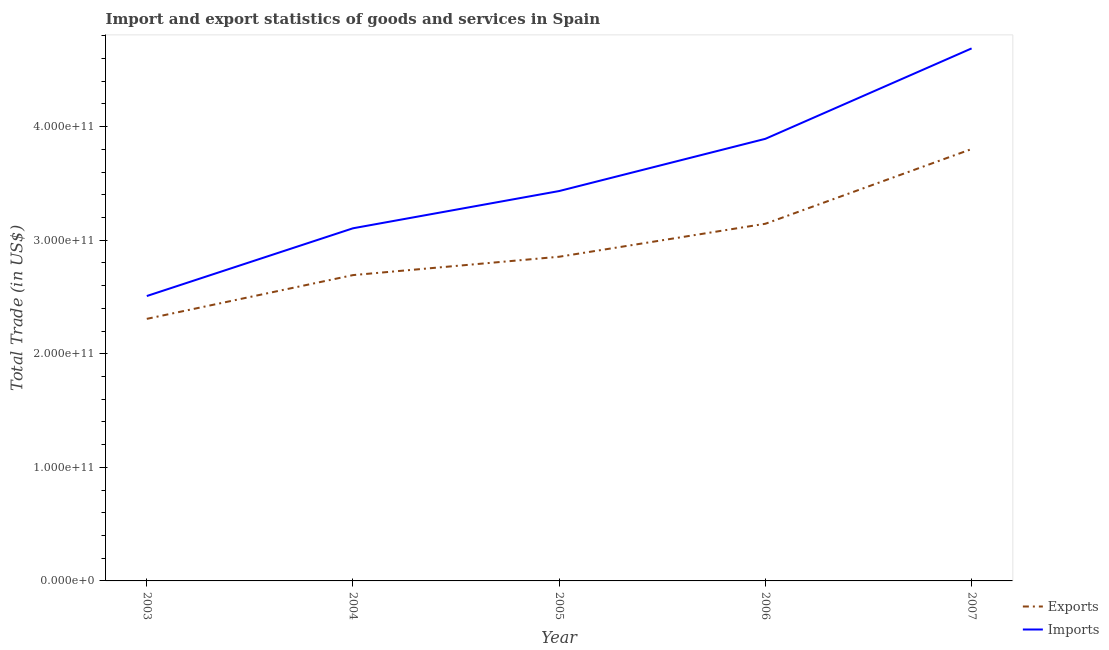How many different coloured lines are there?
Your answer should be compact. 2. What is the imports of goods and services in 2003?
Offer a very short reply. 2.51e+11. Across all years, what is the maximum export of goods and services?
Your answer should be very brief. 3.80e+11. Across all years, what is the minimum export of goods and services?
Ensure brevity in your answer.  2.31e+11. In which year was the imports of goods and services maximum?
Your answer should be compact. 2007. What is the total export of goods and services in the graph?
Keep it short and to the point. 1.48e+12. What is the difference between the export of goods and services in 2005 and that in 2007?
Offer a terse response. -9.48e+1. What is the difference between the export of goods and services in 2005 and the imports of goods and services in 2007?
Give a very brief answer. -1.83e+11. What is the average imports of goods and services per year?
Provide a short and direct response. 3.53e+11. In the year 2007, what is the difference between the imports of goods and services and export of goods and services?
Your answer should be very brief. 8.86e+1. What is the ratio of the export of goods and services in 2003 to that in 2004?
Keep it short and to the point. 0.86. What is the difference between the highest and the second highest export of goods and services?
Ensure brevity in your answer.  6.58e+1. What is the difference between the highest and the lowest export of goods and services?
Your answer should be compact. 1.50e+11. Is the sum of the export of goods and services in 2006 and 2007 greater than the maximum imports of goods and services across all years?
Offer a very short reply. Yes. Does the imports of goods and services monotonically increase over the years?
Give a very brief answer. Yes. How many lines are there?
Your answer should be very brief. 2. What is the difference between two consecutive major ticks on the Y-axis?
Offer a very short reply. 1.00e+11. Does the graph contain any zero values?
Your answer should be very brief. No. Does the graph contain grids?
Provide a short and direct response. No. How many legend labels are there?
Your response must be concise. 2. What is the title of the graph?
Keep it short and to the point. Import and export statistics of goods and services in Spain. What is the label or title of the X-axis?
Offer a very short reply. Year. What is the label or title of the Y-axis?
Your answer should be very brief. Total Trade (in US$). What is the Total Trade (in US$) in Exports in 2003?
Give a very brief answer. 2.31e+11. What is the Total Trade (in US$) of Imports in 2003?
Your answer should be very brief. 2.51e+11. What is the Total Trade (in US$) of Exports in 2004?
Offer a terse response. 2.69e+11. What is the Total Trade (in US$) in Imports in 2004?
Offer a terse response. 3.11e+11. What is the Total Trade (in US$) of Exports in 2005?
Offer a very short reply. 2.85e+11. What is the Total Trade (in US$) of Imports in 2005?
Keep it short and to the point. 3.43e+11. What is the Total Trade (in US$) of Exports in 2006?
Your answer should be very brief. 3.15e+11. What is the Total Trade (in US$) of Imports in 2006?
Offer a terse response. 3.89e+11. What is the Total Trade (in US$) of Exports in 2007?
Provide a succinct answer. 3.80e+11. What is the Total Trade (in US$) of Imports in 2007?
Make the answer very short. 4.69e+11. Across all years, what is the maximum Total Trade (in US$) in Exports?
Make the answer very short. 3.80e+11. Across all years, what is the maximum Total Trade (in US$) of Imports?
Your response must be concise. 4.69e+11. Across all years, what is the minimum Total Trade (in US$) of Exports?
Your response must be concise. 2.31e+11. Across all years, what is the minimum Total Trade (in US$) of Imports?
Offer a very short reply. 2.51e+11. What is the total Total Trade (in US$) in Exports in the graph?
Keep it short and to the point. 1.48e+12. What is the total Total Trade (in US$) of Imports in the graph?
Your answer should be very brief. 1.76e+12. What is the difference between the Total Trade (in US$) in Exports in 2003 and that in 2004?
Your response must be concise. -3.85e+1. What is the difference between the Total Trade (in US$) of Imports in 2003 and that in 2004?
Your answer should be compact. -5.97e+1. What is the difference between the Total Trade (in US$) of Exports in 2003 and that in 2005?
Ensure brevity in your answer.  -5.47e+1. What is the difference between the Total Trade (in US$) in Imports in 2003 and that in 2005?
Offer a terse response. -9.25e+1. What is the difference between the Total Trade (in US$) in Exports in 2003 and that in 2006?
Provide a short and direct response. -8.37e+1. What is the difference between the Total Trade (in US$) of Imports in 2003 and that in 2006?
Provide a succinct answer. -1.38e+11. What is the difference between the Total Trade (in US$) in Exports in 2003 and that in 2007?
Offer a very short reply. -1.50e+11. What is the difference between the Total Trade (in US$) in Imports in 2003 and that in 2007?
Provide a succinct answer. -2.18e+11. What is the difference between the Total Trade (in US$) in Exports in 2004 and that in 2005?
Offer a terse response. -1.62e+1. What is the difference between the Total Trade (in US$) in Imports in 2004 and that in 2005?
Your response must be concise. -3.28e+1. What is the difference between the Total Trade (in US$) in Exports in 2004 and that in 2006?
Offer a terse response. -4.52e+1. What is the difference between the Total Trade (in US$) in Imports in 2004 and that in 2006?
Your answer should be very brief. -7.88e+1. What is the difference between the Total Trade (in US$) in Exports in 2004 and that in 2007?
Your answer should be compact. -1.11e+11. What is the difference between the Total Trade (in US$) of Imports in 2004 and that in 2007?
Make the answer very short. -1.58e+11. What is the difference between the Total Trade (in US$) of Exports in 2005 and that in 2006?
Offer a terse response. -2.90e+1. What is the difference between the Total Trade (in US$) in Imports in 2005 and that in 2006?
Your answer should be very brief. -4.60e+1. What is the difference between the Total Trade (in US$) in Exports in 2005 and that in 2007?
Keep it short and to the point. -9.48e+1. What is the difference between the Total Trade (in US$) in Imports in 2005 and that in 2007?
Your response must be concise. -1.26e+11. What is the difference between the Total Trade (in US$) in Exports in 2006 and that in 2007?
Make the answer very short. -6.58e+1. What is the difference between the Total Trade (in US$) in Imports in 2006 and that in 2007?
Your answer should be very brief. -7.96e+1. What is the difference between the Total Trade (in US$) in Exports in 2003 and the Total Trade (in US$) in Imports in 2004?
Provide a short and direct response. -7.98e+1. What is the difference between the Total Trade (in US$) in Exports in 2003 and the Total Trade (in US$) in Imports in 2005?
Offer a terse response. -1.13e+11. What is the difference between the Total Trade (in US$) of Exports in 2003 and the Total Trade (in US$) of Imports in 2006?
Your response must be concise. -1.59e+11. What is the difference between the Total Trade (in US$) of Exports in 2003 and the Total Trade (in US$) of Imports in 2007?
Make the answer very short. -2.38e+11. What is the difference between the Total Trade (in US$) in Exports in 2004 and the Total Trade (in US$) in Imports in 2005?
Your response must be concise. -7.40e+1. What is the difference between the Total Trade (in US$) of Exports in 2004 and the Total Trade (in US$) of Imports in 2006?
Make the answer very short. -1.20e+11. What is the difference between the Total Trade (in US$) in Exports in 2004 and the Total Trade (in US$) in Imports in 2007?
Provide a succinct answer. -2.00e+11. What is the difference between the Total Trade (in US$) of Exports in 2005 and the Total Trade (in US$) of Imports in 2006?
Ensure brevity in your answer.  -1.04e+11. What is the difference between the Total Trade (in US$) in Exports in 2005 and the Total Trade (in US$) in Imports in 2007?
Provide a succinct answer. -1.83e+11. What is the difference between the Total Trade (in US$) of Exports in 2006 and the Total Trade (in US$) of Imports in 2007?
Give a very brief answer. -1.54e+11. What is the average Total Trade (in US$) in Exports per year?
Ensure brevity in your answer.  2.96e+11. What is the average Total Trade (in US$) of Imports per year?
Keep it short and to the point. 3.53e+11. In the year 2003, what is the difference between the Total Trade (in US$) in Exports and Total Trade (in US$) in Imports?
Ensure brevity in your answer.  -2.01e+1. In the year 2004, what is the difference between the Total Trade (in US$) in Exports and Total Trade (in US$) in Imports?
Your answer should be very brief. -4.12e+1. In the year 2005, what is the difference between the Total Trade (in US$) of Exports and Total Trade (in US$) of Imports?
Give a very brief answer. -5.79e+1. In the year 2006, what is the difference between the Total Trade (in US$) in Exports and Total Trade (in US$) in Imports?
Your answer should be compact. -7.48e+1. In the year 2007, what is the difference between the Total Trade (in US$) of Exports and Total Trade (in US$) of Imports?
Your answer should be compact. -8.86e+1. What is the ratio of the Total Trade (in US$) in Exports in 2003 to that in 2004?
Ensure brevity in your answer.  0.86. What is the ratio of the Total Trade (in US$) of Imports in 2003 to that in 2004?
Your answer should be compact. 0.81. What is the ratio of the Total Trade (in US$) in Exports in 2003 to that in 2005?
Make the answer very short. 0.81. What is the ratio of the Total Trade (in US$) of Imports in 2003 to that in 2005?
Your answer should be very brief. 0.73. What is the ratio of the Total Trade (in US$) in Exports in 2003 to that in 2006?
Offer a very short reply. 0.73. What is the ratio of the Total Trade (in US$) of Imports in 2003 to that in 2006?
Keep it short and to the point. 0.64. What is the ratio of the Total Trade (in US$) of Exports in 2003 to that in 2007?
Offer a terse response. 0.61. What is the ratio of the Total Trade (in US$) of Imports in 2003 to that in 2007?
Give a very brief answer. 0.54. What is the ratio of the Total Trade (in US$) in Exports in 2004 to that in 2005?
Your response must be concise. 0.94. What is the ratio of the Total Trade (in US$) of Imports in 2004 to that in 2005?
Your answer should be compact. 0.9. What is the ratio of the Total Trade (in US$) of Exports in 2004 to that in 2006?
Provide a succinct answer. 0.86. What is the ratio of the Total Trade (in US$) in Imports in 2004 to that in 2006?
Provide a short and direct response. 0.8. What is the ratio of the Total Trade (in US$) in Exports in 2004 to that in 2007?
Provide a succinct answer. 0.71. What is the ratio of the Total Trade (in US$) in Imports in 2004 to that in 2007?
Give a very brief answer. 0.66. What is the ratio of the Total Trade (in US$) in Exports in 2005 to that in 2006?
Offer a very short reply. 0.91. What is the ratio of the Total Trade (in US$) in Imports in 2005 to that in 2006?
Make the answer very short. 0.88. What is the ratio of the Total Trade (in US$) in Exports in 2005 to that in 2007?
Provide a short and direct response. 0.75. What is the ratio of the Total Trade (in US$) in Imports in 2005 to that in 2007?
Offer a terse response. 0.73. What is the ratio of the Total Trade (in US$) in Exports in 2006 to that in 2007?
Give a very brief answer. 0.83. What is the ratio of the Total Trade (in US$) in Imports in 2006 to that in 2007?
Ensure brevity in your answer.  0.83. What is the difference between the highest and the second highest Total Trade (in US$) of Exports?
Offer a very short reply. 6.58e+1. What is the difference between the highest and the second highest Total Trade (in US$) of Imports?
Offer a terse response. 7.96e+1. What is the difference between the highest and the lowest Total Trade (in US$) in Exports?
Ensure brevity in your answer.  1.50e+11. What is the difference between the highest and the lowest Total Trade (in US$) of Imports?
Ensure brevity in your answer.  2.18e+11. 